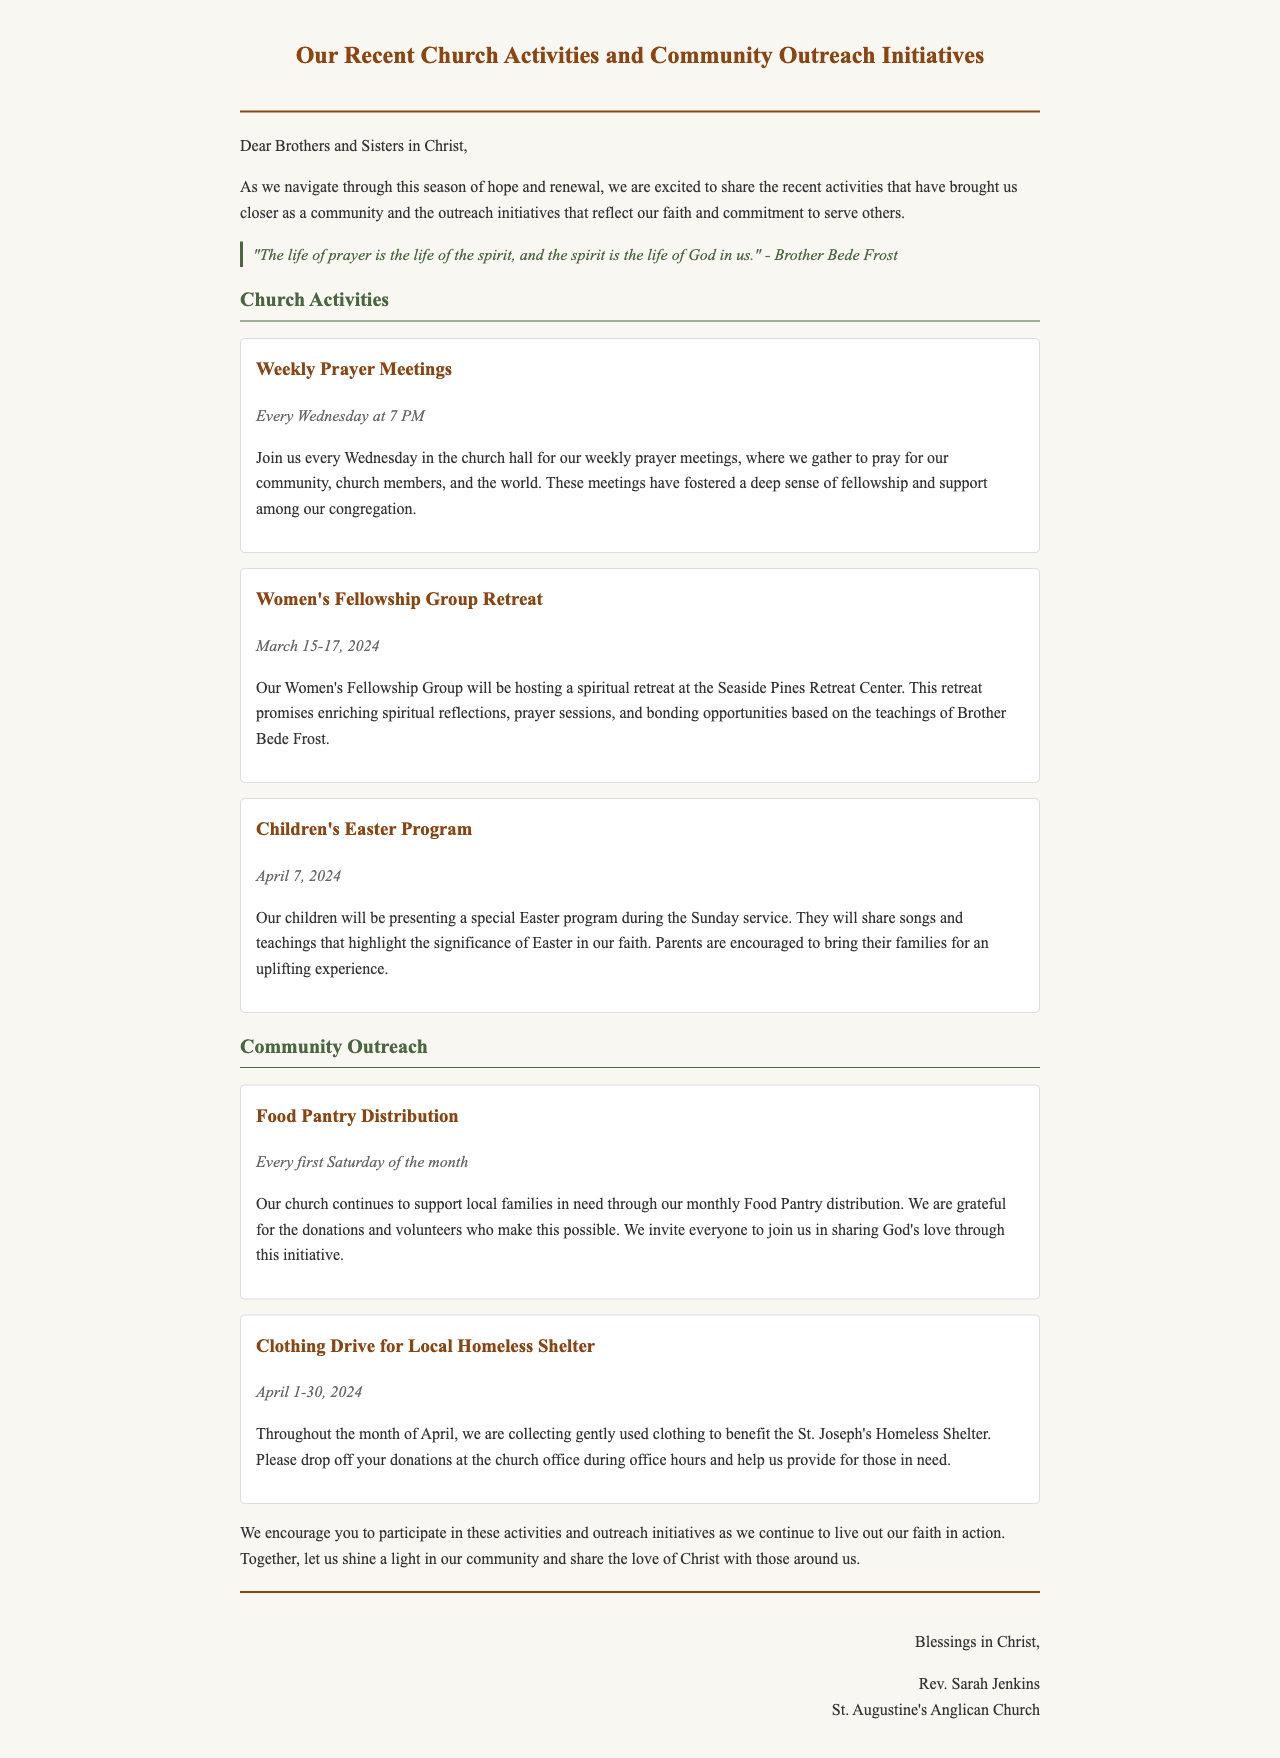What is the title of the newsletter? The title of the newsletter is provided at the top of the document, which reflects the content being shared.
Answer: Our Recent Church Activities and Community Outreach Initiatives When is the Women's Fellowship Group Retreat? The date for the Women's Fellowship Group Retreat is stated in the section detailing church activities.
Answer: March 15-17, 2024 What time do the Weekly Prayer Meetings occur? The time for the Weekly Prayer Meetings is specified in the church activities section of the document.
Answer: 7 PM What is being collected during the Clothing Drive? The type of donations being collected for the Clothing Drive is described in the community outreach section.
Answer: Gently used clothing Who is the author of the email? The author of the email is mentioned at the end of the document, providing identification for the sender.
Answer: Rev. Sarah Jenkins What quote is included in the newsletter? The quote is an important spiritual reflection included in the newsletter to inspire the readers.
Answer: "The life of prayer is the life of the spirit, and the spirit is the life of God in us." - Brother Bede Frost How often does the Food Pantry Distribution occur? The frequency of the Food Pantry Distribution is mentioned in the community outreach section of the document.
Answer: Every first Saturday of the month What is the name of the children’s program mentioned? The children’s program being highlighted in the newsletter is specifically titled in the church activities section.
Answer: Children's Easter Program 